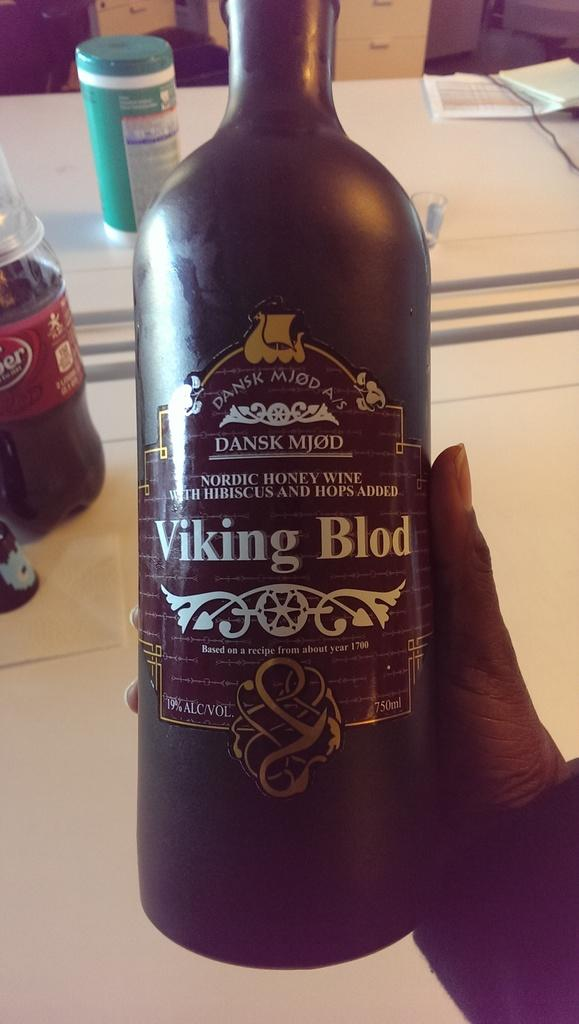Provide a one-sentence caption for the provided image. a bottle of Viking Blod wine held in someone's hand. 